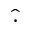<formula> <loc_0><loc_0><loc_500><loc_500>\widehat { \cdot }</formula> 